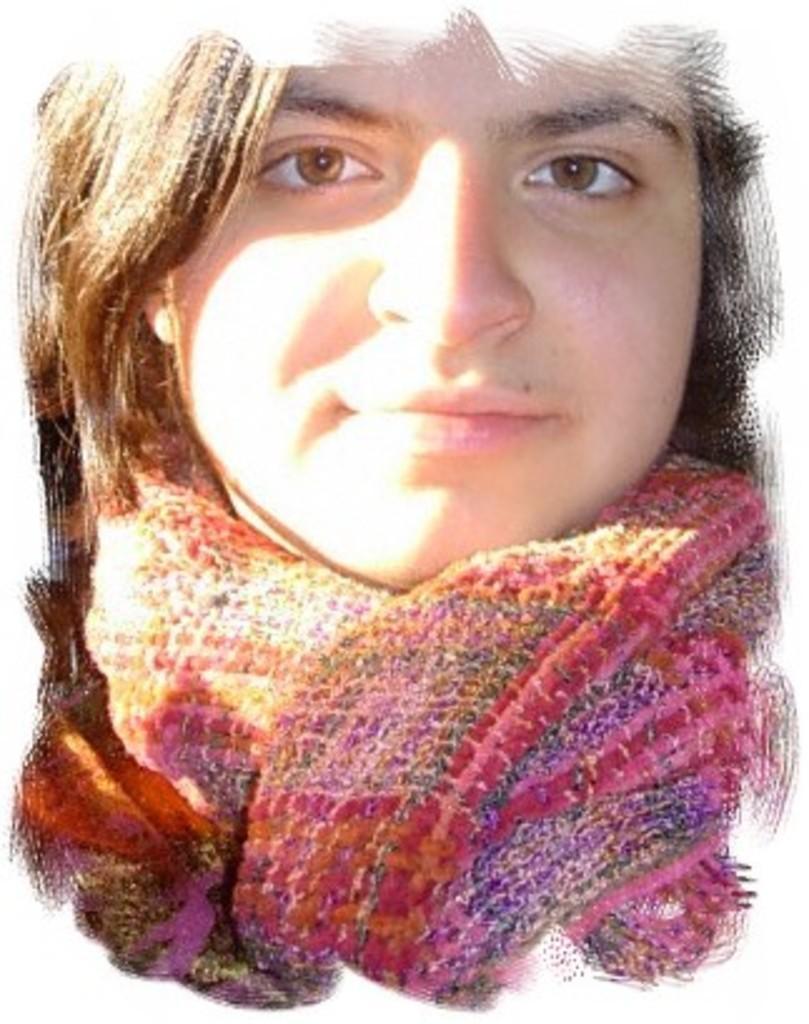In one or two sentences, can you explain what this image depicts? This is an edited image of a person wearing a neck scarf. 